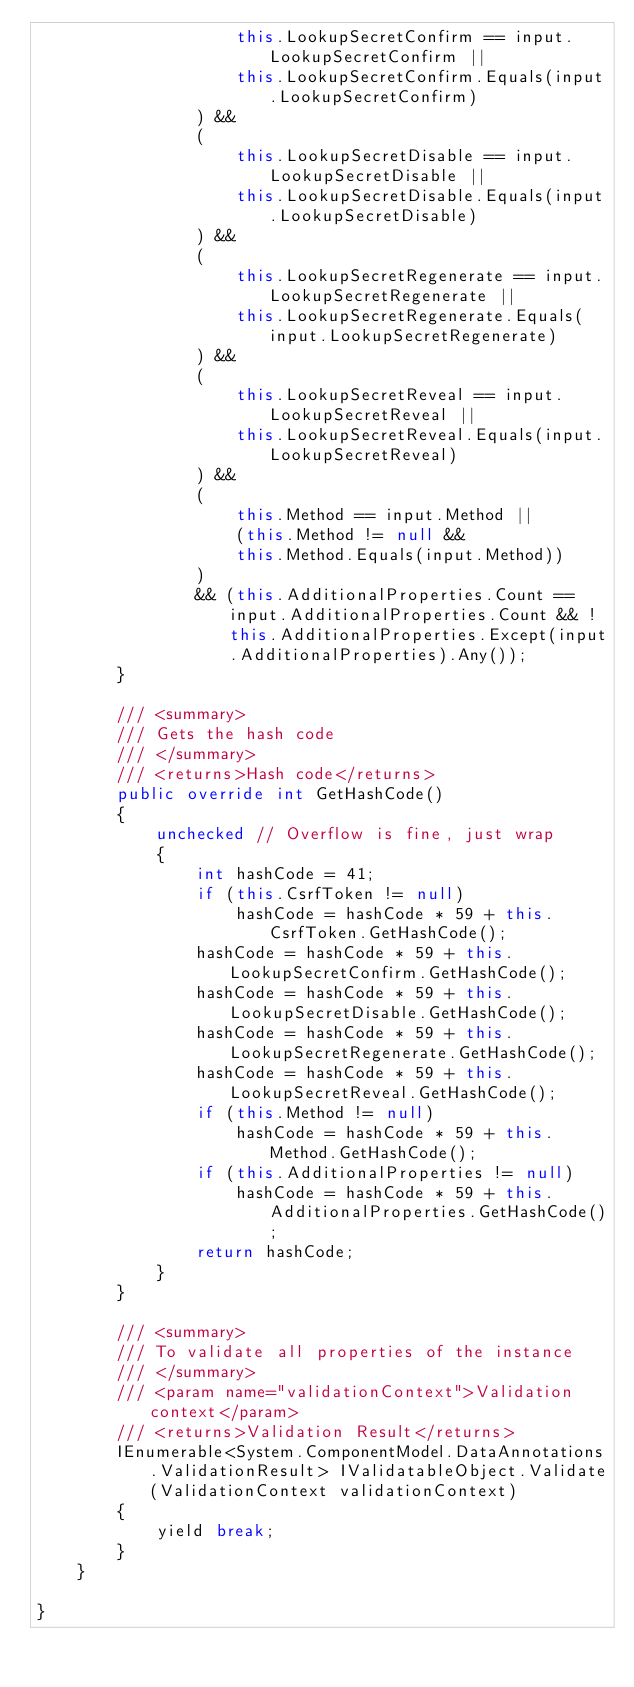<code> <loc_0><loc_0><loc_500><loc_500><_C#_>                    this.LookupSecretConfirm == input.LookupSecretConfirm ||
                    this.LookupSecretConfirm.Equals(input.LookupSecretConfirm)
                ) && 
                (
                    this.LookupSecretDisable == input.LookupSecretDisable ||
                    this.LookupSecretDisable.Equals(input.LookupSecretDisable)
                ) && 
                (
                    this.LookupSecretRegenerate == input.LookupSecretRegenerate ||
                    this.LookupSecretRegenerate.Equals(input.LookupSecretRegenerate)
                ) && 
                (
                    this.LookupSecretReveal == input.LookupSecretReveal ||
                    this.LookupSecretReveal.Equals(input.LookupSecretReveal)
                ) && 
                (
                    this.Method == input.Method ||
                    (this.Method != null &&
                    this.Method.Equals(input.Method))
                )
                && (this.AdditionalProperties.Count == input.AdditionalProperties.Count && !this.AdditionalProperties.Except(input.AdditionalProperties).Any());
        }

        /// <summary>
        /// Gets the hash code
        /// </summary>
        /// <returns>Hash code</returns>
        public override int GetHashCode()
        {
            unchecked // Overflow is fine, just wrap
            {
                int hashCode = 41;
                if (this.CsrfToken != null)
                    hashCode = hashCode * 59 + this.CsrfToken.GetHashCode();
                hashCode = hashCode * 59 + this.LookupSecretConfirm.GetHashCode();
                hashCode = hashCode * 59 + this.LookupSecretDisable.GetHashCode();
                hashCode = hashCode * 59 + this.LookupSecretRegenerate.GetHashCode();
                hashCode = hashCode * 59 + this.LookupSecretReveal.GetHashCode();
                if (this.Method != null)
                    hashCode = hashCode * 59 + this.Method.GetHashCode();
                if (this.AdditionalProperties != null)
                    hashCode = hashCode * 59 + this.AdditionalProperties.GetHashCode();
                return hashCode;
            }
        }

        /// <summary>
        /// To validate all properties of the instance
        /// </summary>
        /// <param name="validationContext">Validation context</param>
        /// <returns>Validation Result</returns>
        IEnumerable<System.ComponentModel.DataAnnotations.ValidationResult> IValidatableObject.Validate(ValidationContext validationContext)
        {
            yield break;
        }
    }

}
</code> 